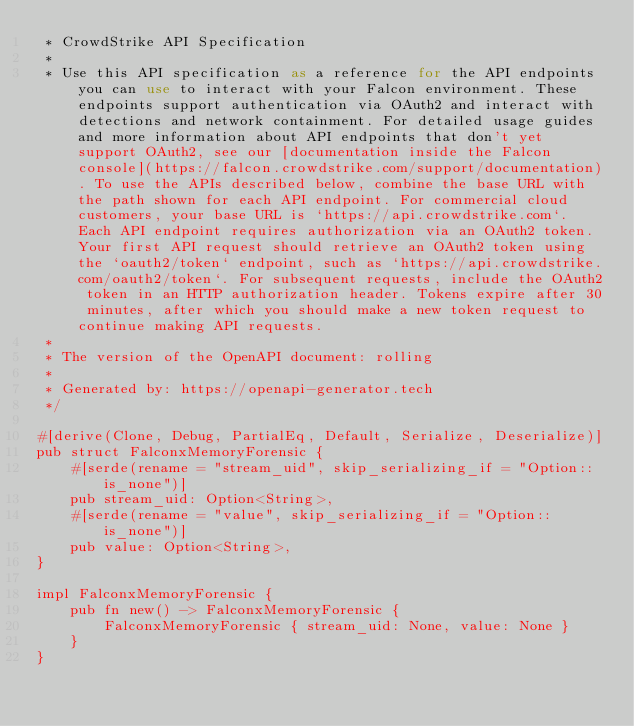<code> <loc_0><loc_0><loc_500><loc_500><_Rust_> * CrowdStrike API Specification
 *
 * Use this API specification as a reference for the API endpoints you can use to interact with your Falcon environment. These endpoints support authentication via OAuth2 and interact with detections and network containment. For detailed usage guides and more information about API endpoints that don't yet support OAuth2, see our [documentation inside the Falcon console](https://falcon.crowdstrike.com/support/documentation). To use the APIs described below, combine the base URL with the path shown for each API endpoint. For commercial cloud customers, your base URL is `https://api.crowdstrike.com`. Each API endpoint requires authorization via an OAuth2 token. Your first API request should retrieve an OAuth2 token using the `oauth2/token` endpoint, such as `https://api.crowdstrike.com/oauth2/token`. For subsequent requests, include the OAuth2 token in an HTTP authorization header. Tokens expire after 30 minutes, after which you should make a new token request to continue making API requests.
 *
 * The version of the OpenAPI document: rolling
 *
 * Generated by: https://openapi-generator.tech
 */

#[derive(Clone, Debug, PartialEq, Default, Serialize, Deserialize)]
pub struct FalconxMemoryForensic {
    #[serde(rename = "stream_uid", skip_serializing_if = "Option::is_none")]
    pub stream_uid: Option<String>,
    #[serde(rename = "value", skip_serializing_if = "Option::is_none")]
    pub value: Option<String>,
}

impl FalconxMemoryForensic {
    pub fn new() -> FalconxMemoryForensic {
        FalconxMemoryForensic { stream_uid: None, value: None }
    }
}
</code> 